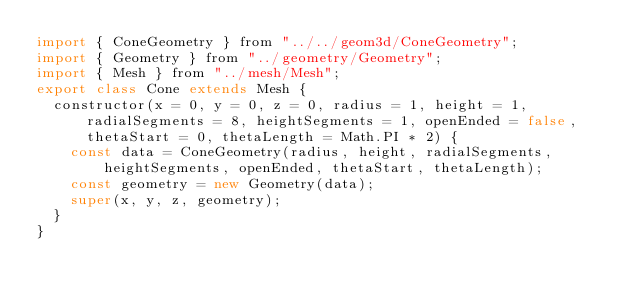<code> <loc_0><loc_0><loc_500><loc_500><_JavaScript_>import { ConeGeometry } from "../../geom3d/ConeGeometry";
import { Geometry } from "../geometry/Geometry";
import { Mesh } from "../mesh/Mesh";
export class Cone extends Mesh {
  constructor(x = 0, y = 0, z = 0, radius = 1, height = 1, radialSegments = 8, heightSegments = 1, openEnded = false, thetaStart = 0, thetaLength = Math.PI * 2) {
    const data = ConeGeometry(radius, height, radialSegments, heightSegments, openEnded, thetaStart, thetaLength);
    const geometry = new Geometry(data);
    super(x, y, z, geometry);
  }
}
</code> 